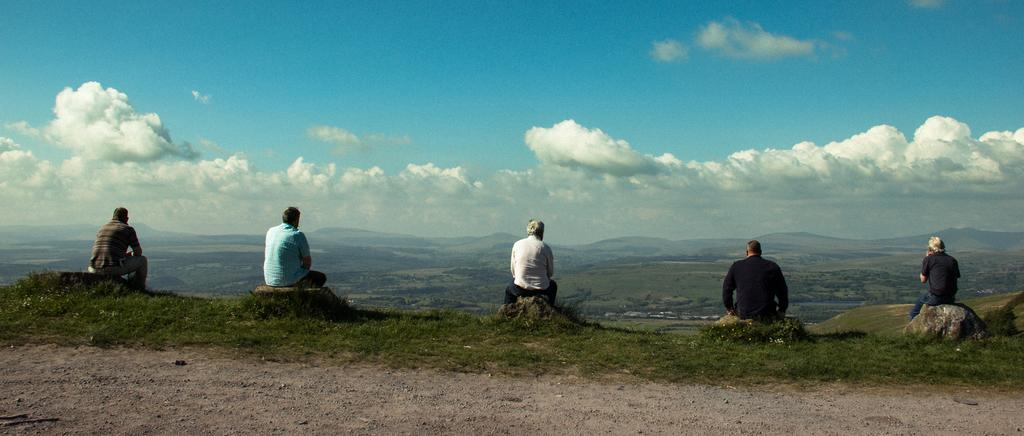What is happening in the middle of the image? There is a group of persons sitting in the middle of the image. What can be seen in the background of the image? There are hills in the background of the image. What is visible at the top of the image? The sky is visible at the top of the image. What type of books can be seen in the library in the image? There is no library present in the image; it features a group of persons sitting and hills in the background. How do the persons in the image fly to the top of the hills? The persons in the image are sitting and not flying; there is no indication of any flying activity in the image. 